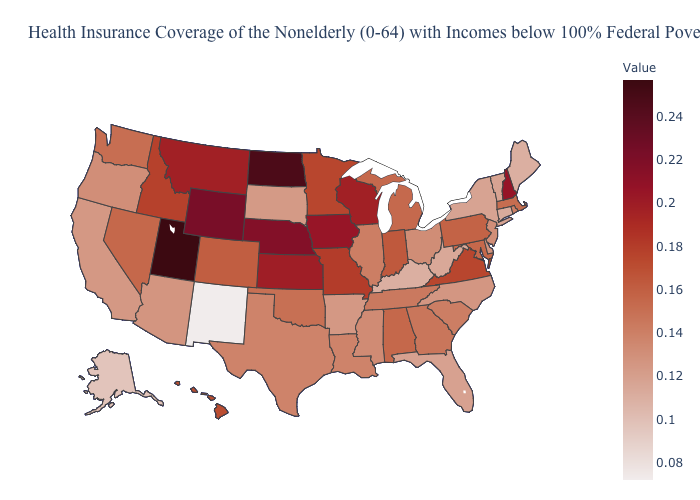Among the states that border Kentucky , does Tennessee have the lowest value?
Answer briefly. No. Which states have the lowest value in the MidWest?
Keep it brief. South Dakota. Which states have the lowest value in the USA?
Keep it brief. New Mexico. Among the states that border Michigan , which have the highest value?
Give a very brief answer. Wisconsin. Among the states that border Arkansas , which have the highest value?
Quick response, please. Missouri. 